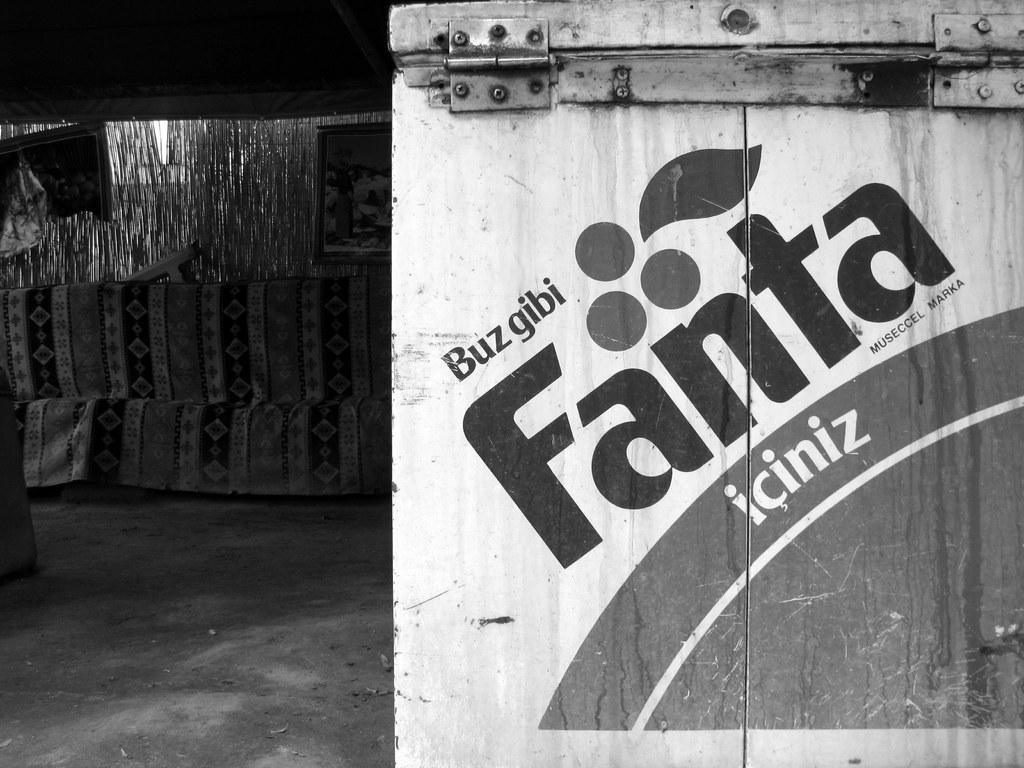What is the main object in the image? There is a box in the image. What is written on the box? The box has "fanta" written on it. Can you describe any other objects or elements visible in the image? There are other items visible in the background of the image. How many cabbages can be seen falling from the sky in the image? There are no cabbages visible in the image, nor are any falling from the sky. 